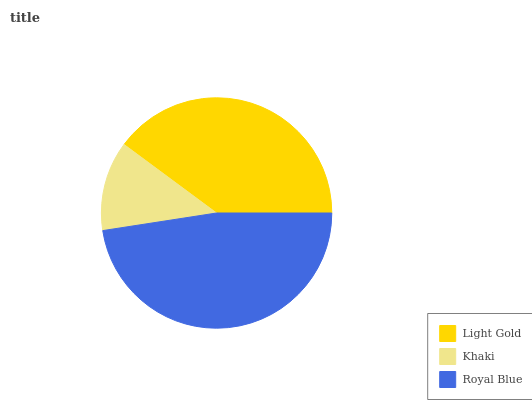Is Khaki the minimum?
Answer yes or no. Yes. Is Royal Blue the maximum?
Answer yes or no. Yes. Is Royal Blue the minimum?
Answer yes or no. No. Is Khaki the maximum?
Answer yes or no. No. Is Royal Blue greater than Khaki?
Answer yes or no. Yes. Is Khaki less than Royal Blue?
Answer yes or no. Yes. Is Khaki greater than Royal Blue?
Answer yes or no. No. Is Royal Blue less than Khaki?
Answer yes or no. No. Is Light Gold the high median?
Answer yes or no. Yes. Is Light Gold the low median?
Answer yes or no. Yes. Is Royal Blue the high median?
Answer yes or no. No. Is Royal Blue the low median?
Answer yes or no. No. 